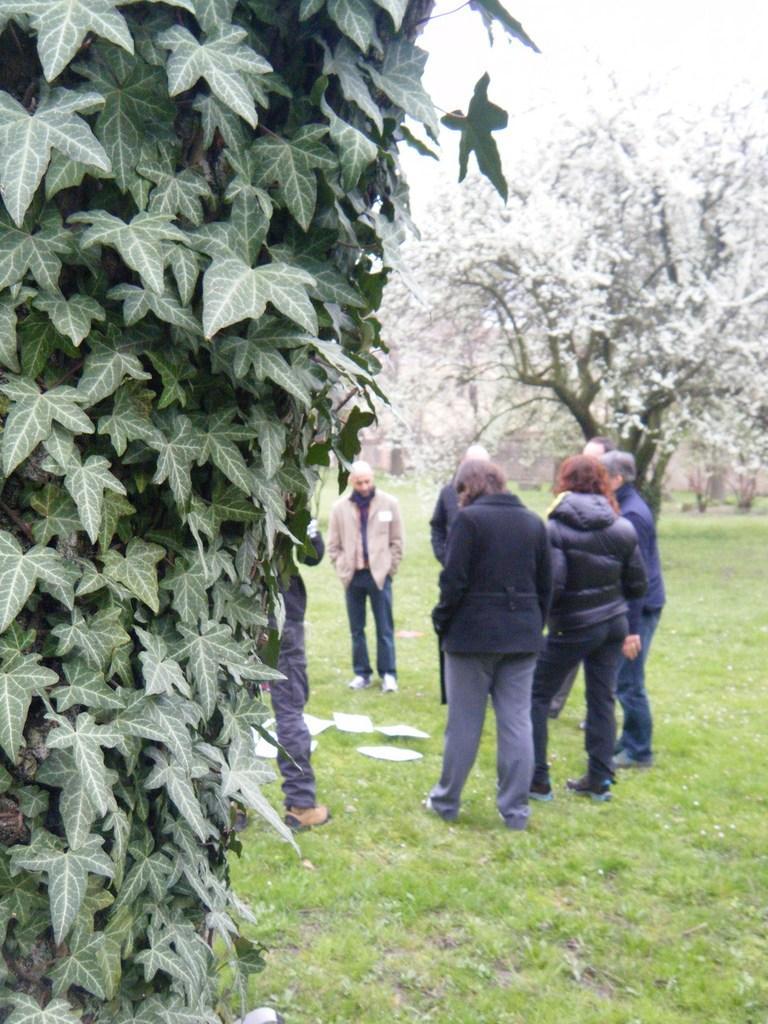Could you give a brief overview of what you see in this image? On the left side of the image, we can see leaves. Background we can see people are standing on the grass. Here there are few objects are placed on the grass. Here we can see few trees. 